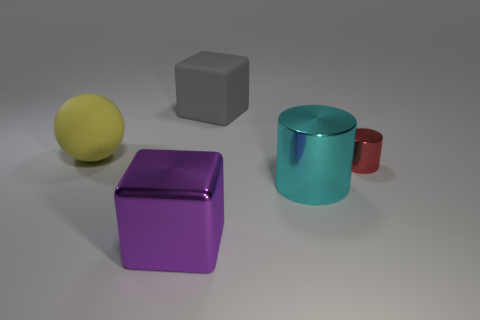Add 5 purple cubes. How many objects exist? 10 Subtract all balls. How many objects are left? 4 Subtract all big yellow rubber cubes. Subtract all big yellow matte spheres. How many objects are left? 4 Add 4 gray matte objects. How many gray matte objects are left? 5 Add 2 metallic objects. How many metallic objects exist? 5 Subtract 0 gray cylinders. How many objects are left? 5 